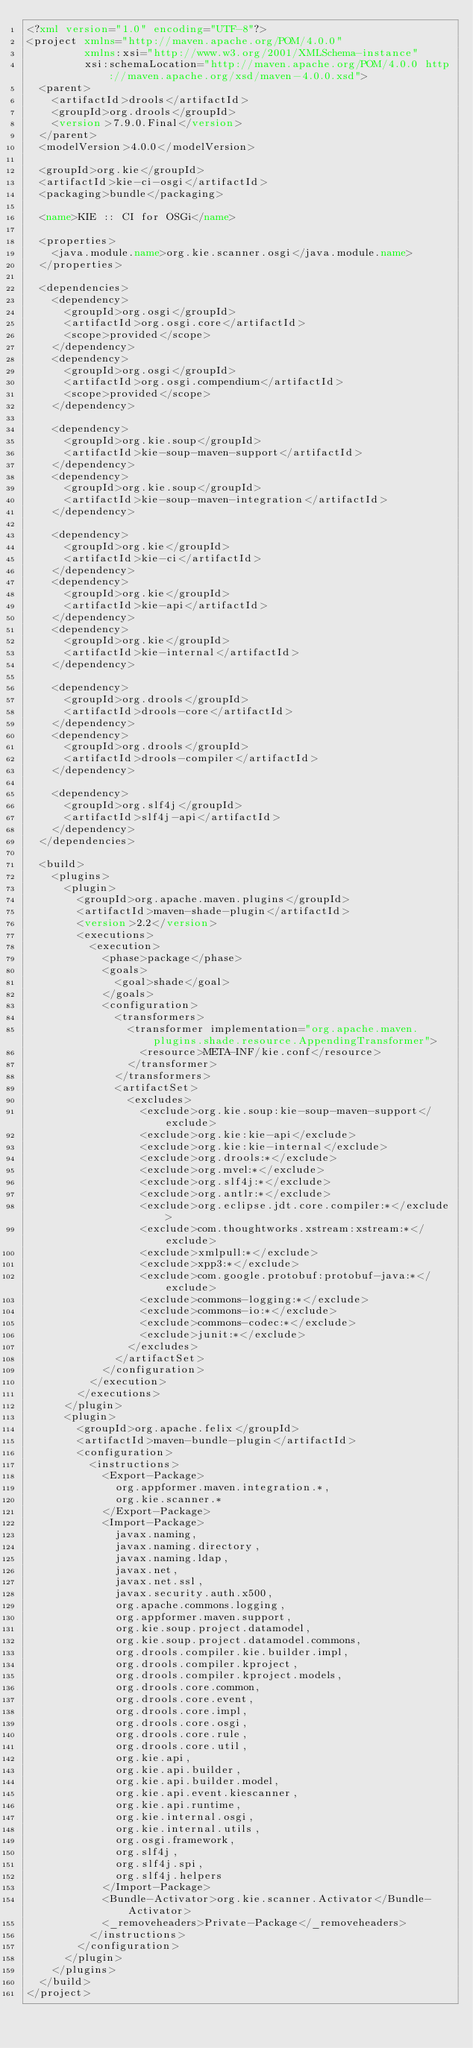<code> <loc_0><loc_0><loc_500><loc_500><_XML_><?xml version="1.0" encoding="UTF-8"?>
<project xmlns="http://maven.apache.org/POM/4.0.0"
         xmlns:xsi="http://www.w3.org/2001/XMLSchema-instance"
         xsi:schemaLocation="http://maven.apache.org/POM/4.0.0 http://maven.apache.org/xsd/maven-4.0.0.xsd">
  <parent>
    <artifactId>drools</artifactId>
    <groupId>org.drools</groupId>
    <version>7.9.0.Final</version>
  </parent>
  <modelVersion>4.0.0</modelVersion>

  <groupId>org.kie</groupId>
  <artifactId>kie-ci-osgi</artifactId>
  <packaging>bundle</packaging>

  <name>KIE :: CI for OSGi</name>

  <properties>
    <java.module.name>org.kie.scanner.osgi</java.module.name>
  </properties>

  <dependencies>
    <dependency>
      <groupId>org.osgi</groupId>
      <artifactId>org.osgi.core</artifactId>
      <scope>provided</scope>
    </dependency>
    <dependency>
      <groupId>org.osgi</groupId>
      <artifactId>org.osgi.compendium</artifactId>
      <scope>provided</scope>
    </dependency>

    <dependency>
      <groupId>org.kie.soup</groupId>
      <artifactId>kie-soup-maven-support</artifactId>
    </dependency>
    <dependency>
      <groupId>org.kie.soup</groupId>
      <artifactId>kie-soup-maven-integration</artifactId>
    </dependency>

    <dependency>
      <groupId>org.kie</groupId>
      <artifactId>kie-ci</artifactId>
    </dependency>
    <dependency>
      <groupId>org.kie</groupId>
      <artifactId>kie-api</artifactId>
    </dependency>
    <dependency>
      <groupId>org.kie</groupId>
      <artifactId>kie-internal</artifactId>
    </dependency>

    <dependency>
      <groupId>org.drools</groupId>
      <artifactId>drools-core</artifactId>
    </dependency>
    <dependency>
      <groupId>org.drools</groupId>
      <artifactId>drools-compiler</artifactId>
    </dependency>

    <dependency>
      <groupId>org.slf4j</groupId>
      <artifactId>slf4j-api</artifactId>
    </dependency>
  </dependencies>

  <build>
    <plugins>
      <plugin>
        <groupId>org.apache.maven.plugins</groupId>
        <artifactId>maven-shade-plugin</artifactId>
        <version>2.2</version>
        <executions>
          <execution>
            <phase>package</phase>
            <goals>
              <goal>shade</goal>
            </goals>
            <configuration>
              <transformers>
                <transformer implementation="org.apache.maven.plugins.shade.resource.AppendingTransformer">
                  <resource>META-INF/kie.conf</resource>
                </transformer>
              </transformers>
              <artifactSet>
                <excludes>
                  <exclude>org.kie.soup:kie-soup-maven-support</exclude>
                  <exclude>org.kie:kie-api</exclude>
                  <exclude>org.kie:kie-internal</exclude>
                  <exclude>org.drools:*</exclude>
                  <exclude>org.mvel:*</exclude>
                  <exclude>org.slf4j:*</exclude>
                  <exclude>org.antlr:*</exclude>
                  <exclude>org.eclipse.jdt.core.compiler:*</exclude>
                  <exclude>com.thoughtworks.xstream:xstream:*</exclude>
                  <exclude>xmlpull:*</exclude>
                  <exclude>xpp3:*</exclude>
                  <exclude>com.google.protobuf:protobuf-java:*</exclude>
                  <exclude>commons-logging:*</exclude>
                  <exclude>commons-io:*</exclude>
                  <exclude>commons-codec:*</exclude>
                  <exclude>junit:*</exclude>
                </excludes>
              </artifactSet>
            </configuration>
          </execution>
        </executions>
      </plugin>
      <plugin>
        <groupId>org.apache.felix</groupId>
        <artifactId>maven-bundle-plugin</artifactId>
        <configuration>
          <instructions>
            <Export-Package>
              org.appformer.maven.integration.*,
              org.kie.scanner.*
            </Export-Package>
            <Import-Package>
              javax.naming,
              javax.naming.directory,
              javax.naming.ldap,
              javax.net,
              javax.net.ssl,
              javax.security.auth.x500,
              org.apache.commons.logging,
              org.appformer.maven.support,
              org.kie.soup.project.datamodel,
              org.kie.soup.project.datamodel.commons,
              org.drools.compiler.kie.builder.impl,
              org.drools.compiler.kproject,
              org.drools.compiler.kproject.models,
              org.drools.core.common,
              org.drools.core.event,
              org.drools.core.impl,
              org.drools.core.osgi,
              org.drools.core.rule,
              org.drools.core.util,
              org.kie.api,
              org.kie.api.builder,
              org.kie.api.builder.model,
              org.kie.api.event.kiescanner,
              org.kie.api.runtime,
              org.kie.internal.osgi,
              org.kie.internal.utils,
              org.osgi.framework,
              org.slf4j,
              org.slf4j.spi,
              org.slf4j.helpers
            </Import-Package>
            <Bundle-Activator>org.kie.scanner.Activator</Bundle-Activator>
            <_removeheaders>Private-Package</_removeheaders>
          </instructions>
        </configuration>
      </plugin>
    </plugins>
  </build>
</project>
</code> 